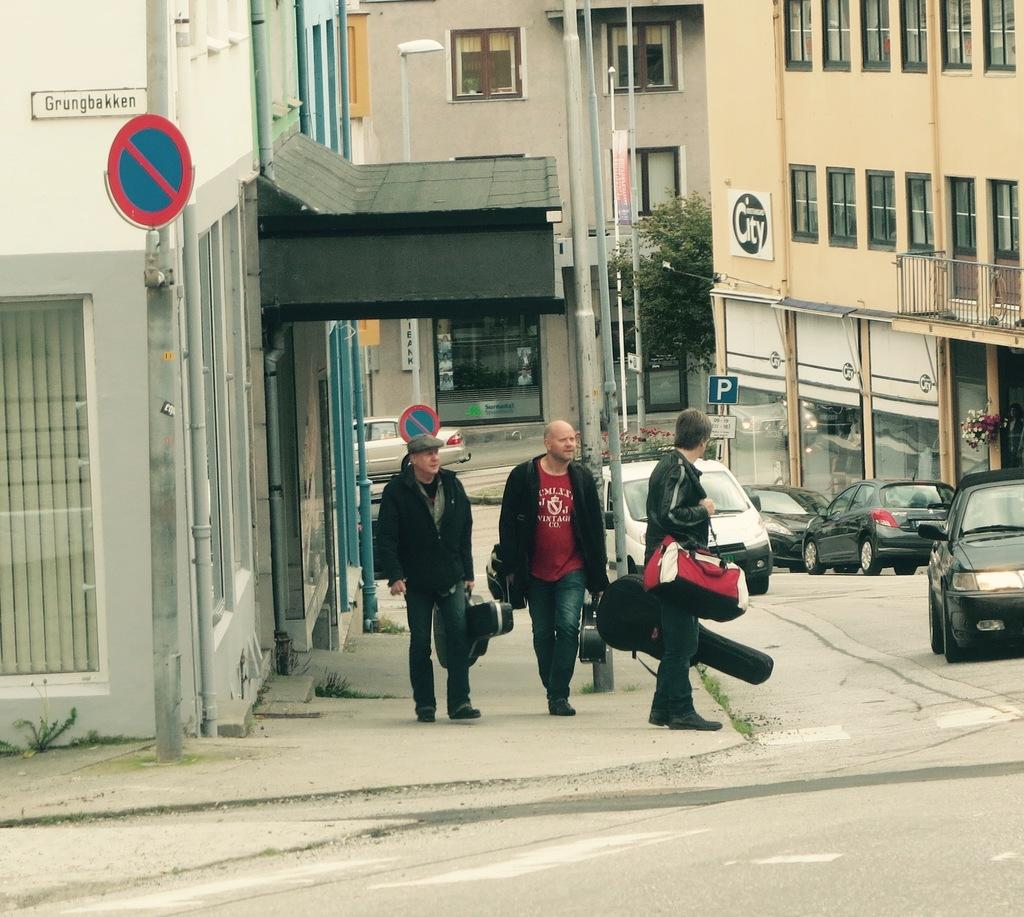Provide a one-sentence caption for the provided image. three musicians are getting ready to cross Grungbakken street. 